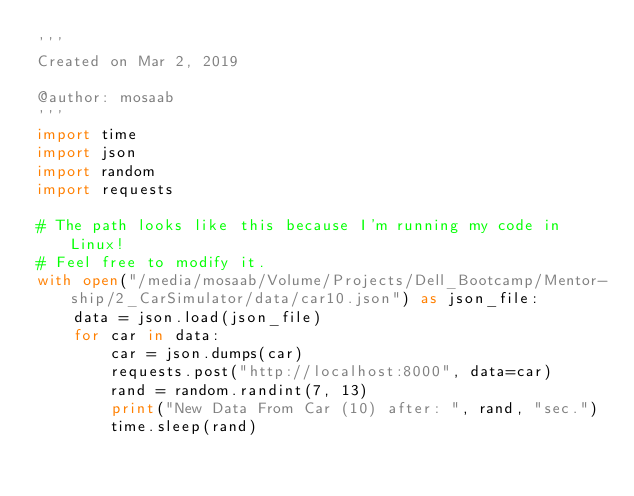Convert code to text. <code><loc_0><loc_0><loc_500><loc_500><_Python_>'''
Created on Mar 2, 2019

@author: mosaab
'''
import time
import json
import random
import requests

# The path looks like this because I'm running my code in Linux!
# Feel free to modify it.
with open("/media/mosaab/Volume/Projects/Dell_Bootcamp/Mentor-ship/2_CarSimulator/data/car10.json") as json_file:
    data = json.load(json_file)
    for car in data:
        car = json.dumps(car)
        requests.post("http://localhost:8000", data=car)
        rand = random.randint(7, 13)
        print("New Data From Car (10) after: ", rand, "sec.")
        time.sleep(rand)</code> 